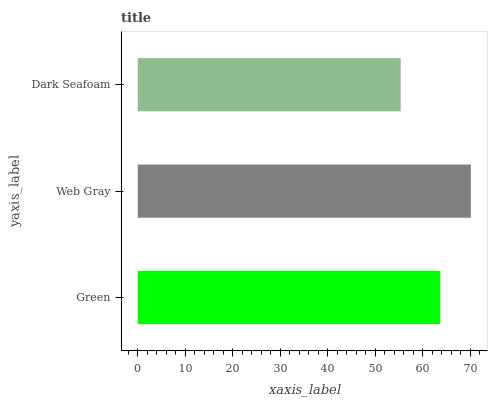Is Dark Seafoam the minimum?
Answer yes or no. Yes. Is Web Gray the maximum?
Answer yes or no. Yes. Is Web Gray the minimum?
Answer yes or no. No. Is Dark Seafoam the maximum?
Answer yes or no. No. Is Web Gray greater than Dark Seafoam?
Answer yes or no. Yes. Is Dark Seafoam less than Web Gray?
Answer yes or no. Yes. Is Dark Seafoam greater than Web Gray?
Answer yes or no. No. Is Web Gray less than Dark Seafoam?
Answer yes or no. No. Is Green the high median?
Answer yes or no. Yes. Is Green the low median?
Answer yes or no. Yes. Is Dark Seafoam the high median?
Answer yes or no. No. Is Dark Seafoam the low median?
Answer yes or no. No. 